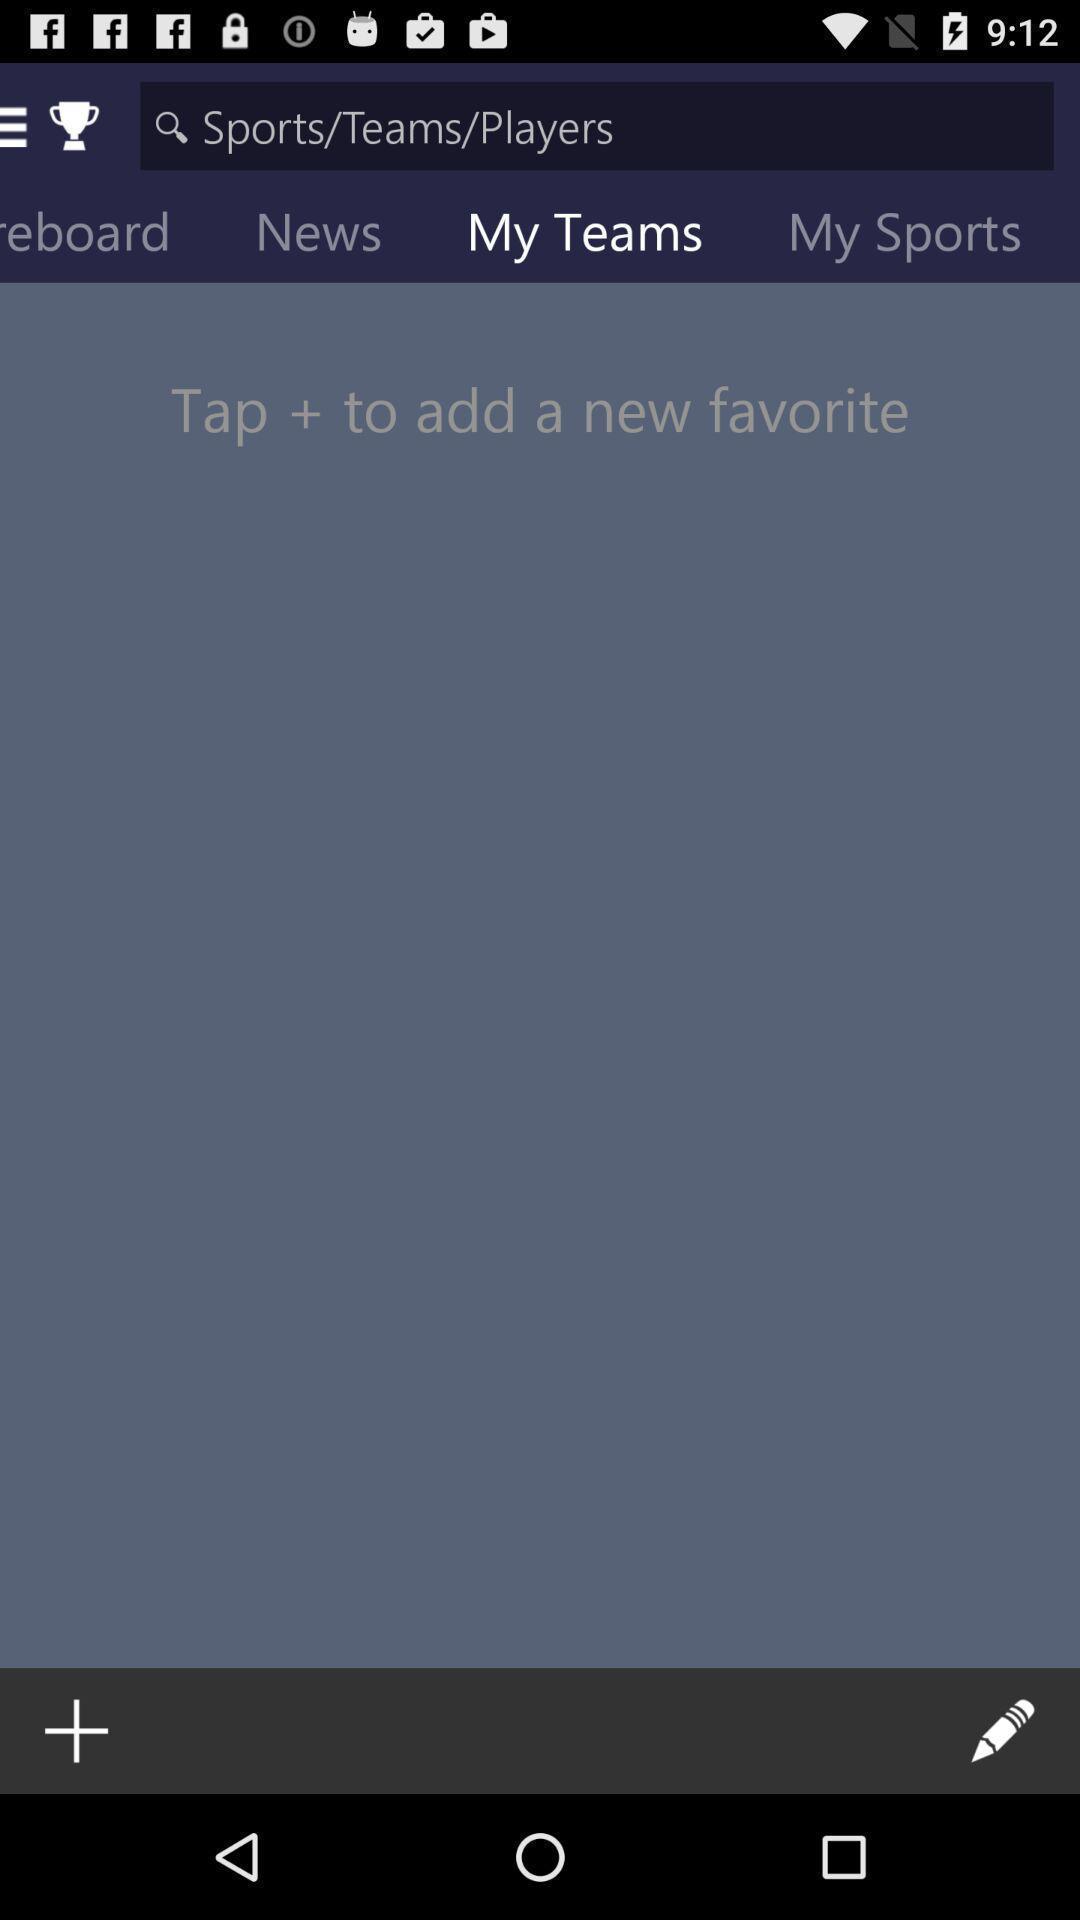Describe the visual elements of this screenshot. Screen page displaying various options in sports application. 